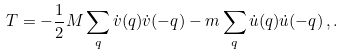Convert formula to latex. <formula><loc_0><loc_0><loc_500><loc_500>T = - \frac { 1 } { 2 } M \sum _ { q } \dot { v } ( q ) \dot { v } ( - q ) - m \sum _ { q } \dot { u } ( q ) \dot { u } ( - q ) \, , .</formula> 